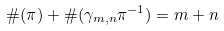<formula> <loc_0><loc_0><loc_500><loc_500>\# ( \pi ) + \# ( \gamma _ { m , n } \pi ^ { - 1 } ) = m + n</formula> 